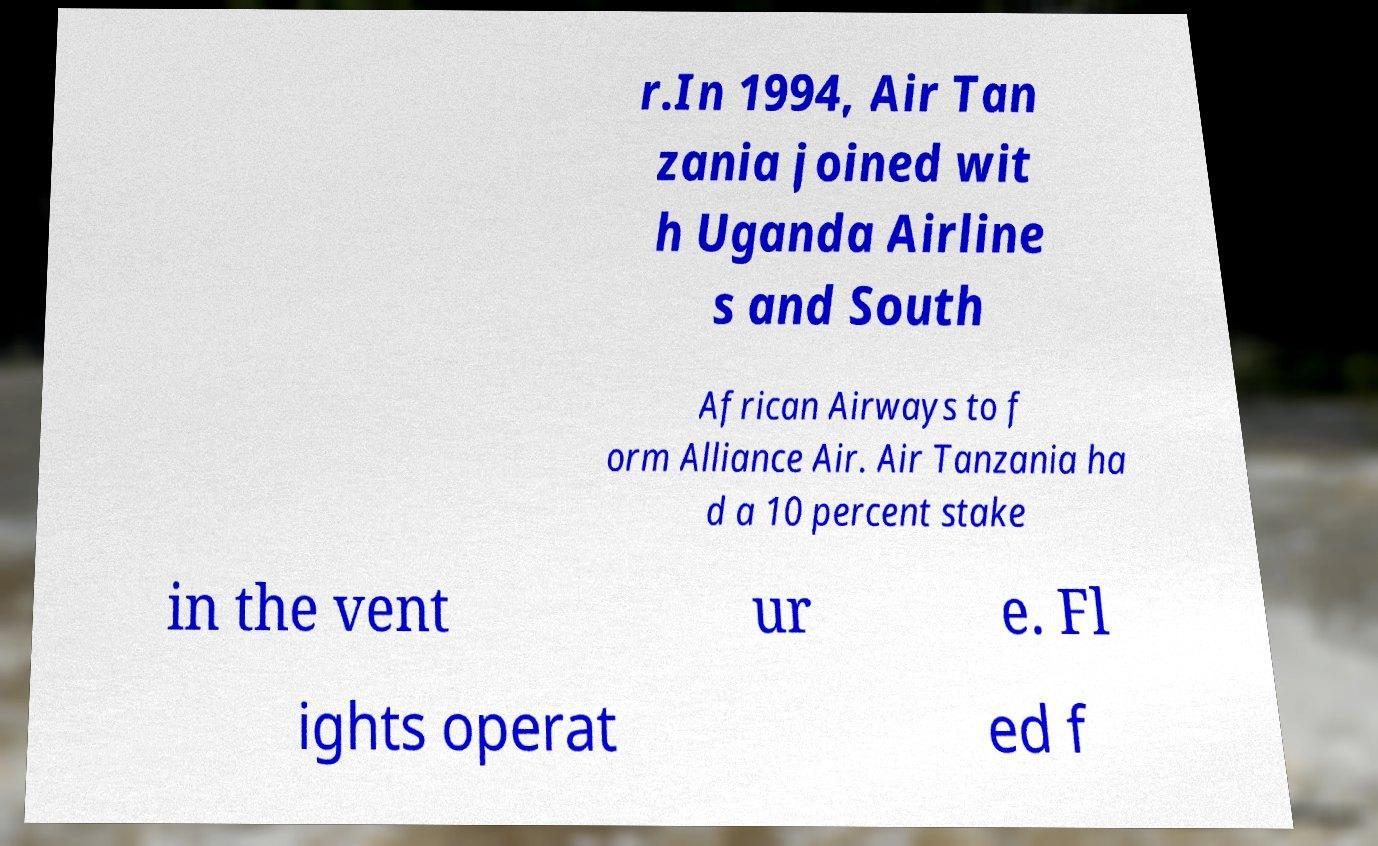Can you read and provide the text displayed in the image?This photo seems to have some interesting text. Can you extract and type it out for me? r.In 1994, Air Tan zania joined wit h Uganda Airline s and South African Airways to f orm Alliance Air. Air Tanzania ha d a 10 percent stake in the vent ur e. Fl ights operat ed f 